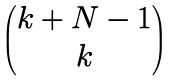Convert formula to latex. <formula><loc_0><loc_0><loc_500><loc_500>\begin{pmatrix} k + N - 1 \\ k \end{pmatrix}</formula> 